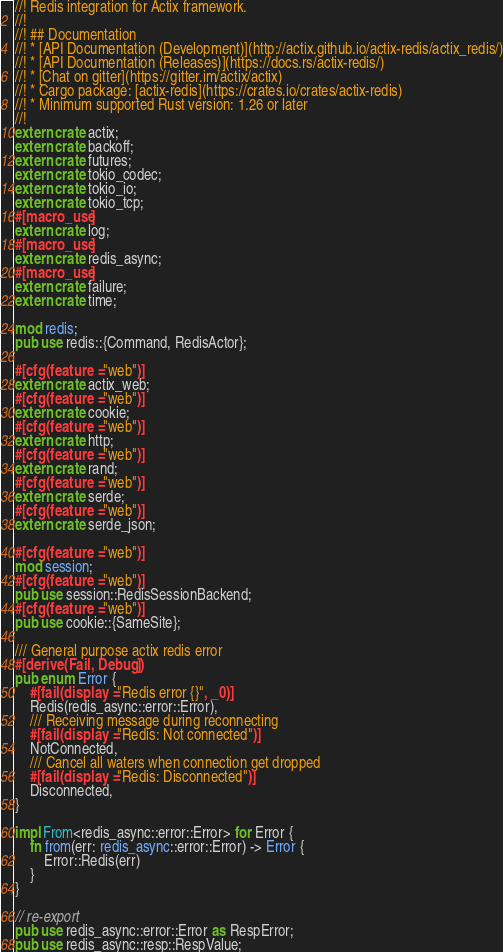<code> <loc_0><loc_0><loc_500><loc_500><_Rust_>//! Redis integration for Actix framework.
//!
//! ## Documentation
//! * [API Documentation (Development)](http://actix.github.io/actix-redis/actix_redis/)
//! * [API Documentation (Releases)](https://docs.rs/actix-redis/)
//! * [Chat on gitter](https://gitter.im/actix/actix)
//! * Cargo package: [actix-redis](https://crates.io/crates/actix-redis)
//! * Minimum supported Rust version: 1.26 or later
//!
extern crate actix;
extern crate backoff;
extern crate futures;
extern crate tokio_codec;
extern crate tokio_io;
extern crate tokio_tcp;
#[macro_use]
extern crate log;
#[macro_use]
extern crate redis_async;
#[macro_use]
extern crate failure;
extern crate time;

mod redis;
pub use redis::{Command, RedisActor};

#[cfg(feature = "web")]
extern crate actix_web;
#[cfg(feature = "web")]
extern crate cookie;
#[cfg(feature = "web")]
extern crate http;
#[cfg(feature = "web")]
extern crate rand;
#[cfg(feature = "web")]
extern crate serde;
#[cfg(feature = "web")]
extern crate serde_json;

#[cfg(feature = "web")]
mod session;
#[cfg(feature = "web")]
pub use session::RedisSessionBackend;
#[cfg(feature = "web")]
pub use cookie::{SameSite};

/// General purpose actix redis error
#[derive(Fail, Debug)]
pub enum Error {
    #[fail(display = "Redis error {}", _0)]
    Redis(redis_async::error::Error),
    /// Receiving message during reconnecting
    #[fail(display = "Redis: Not connected")]
    NotConnected,
    /// Cancel all waters when connection get dropped
    #[fail(display = "Redis: Disconnected")]
    Disconnected,
}

impl From<redis_async::error::Error> for Error {
    fn from(err: redis_async::error::Error) -> Error {
        Error::Redis(err)
    }
}

// re-export
pub use redis_async::error::Error as RespError;
pub use redis_async::resp::RespValue;
</code> 